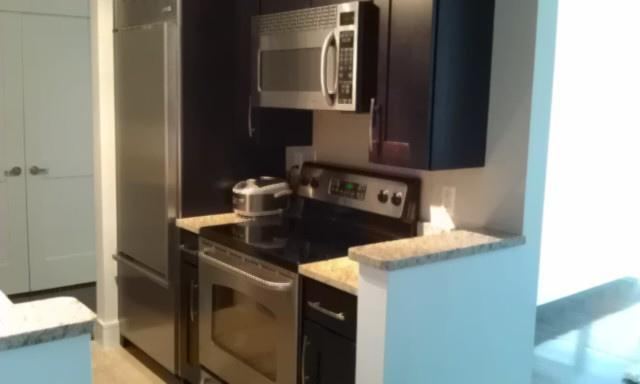What are the appliances made of? stainless steel 